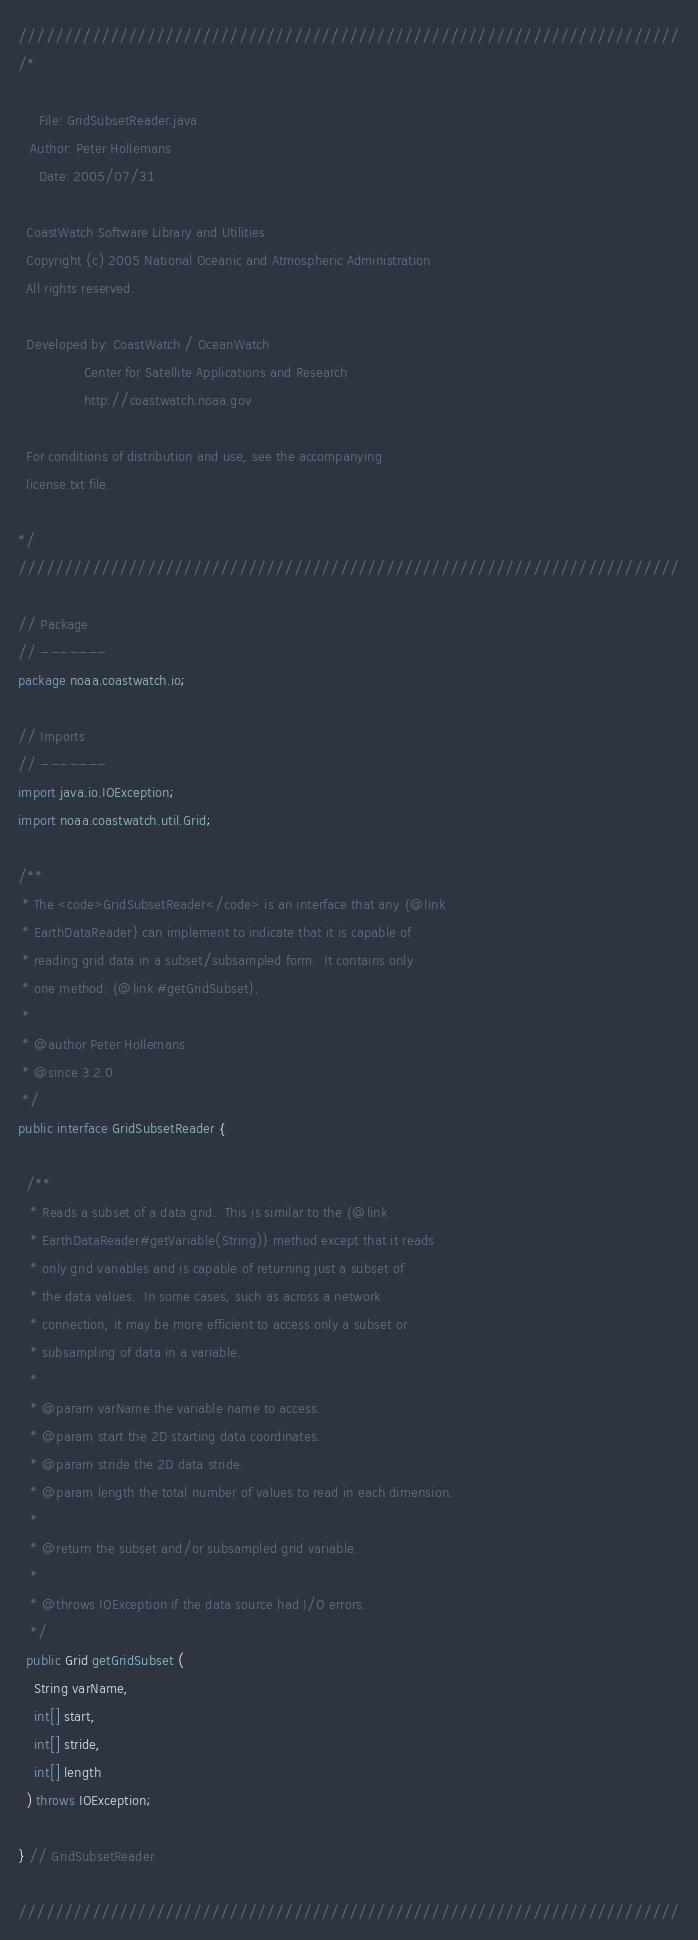<code> <loc_0><loc_0><loc_500><loc_500><_Java_>////////////////////////////////////////////////////////////////////////
/*

     File: GridSubsetReader.java
   Author: Peter Hollemans
     Date: 2005/07/31

  CoastWatch Software Library and Utilities
  Copyright (c) 2005 National Oceanic and Atmospheric Administration
  All rights reserved.

  Developed by: CoastWatch / OceanWatch
                Center for Satellite Applications and Research
                http://coastwatch.noaa.gov

  For conditions of distribution and use, see the accompanying
  license.txt file.

*/
////////////////////////////////////////////////////////////////////////

// Package
// -------
package noaa.coastwatch.io;

// Imports
// -------
import java.io.IOException;
import noaa.coastwatch.util.Grid;

/** 
 * The <code>GridSubsetReader</code> is an interface that any {@link
 * EarthDataReader} can implement to indicate that it is capable of
 * reading grid data in a subset/subsampled form.  It contains only
 * one method: {@link #getGridSubset}.
 *
 * @author Peter Hollemans
 * @since 3.2.0
 */
public interface GridSubsetReader {

  /** 
   * Reads a subset of a data grid.  This is similar to the {@link
   * EarthDataReader#getVariable(String)} method except that it reads
   * only grid variables and is capable of returning just a subset of
   * the data values.  In some cases, such as across a network
   * connection, it may be more efficient to access only a subset or
   * subsampling of data in a variable.
   *
   * @param varName the variable name to access.
   * @param start the 2D starting data coordinates.
   * @param stride the 2D data stride.
   * @param length the total number of values to read in each dimension.
   *
   * @return the subset and/or subsampled grid variable.
   *
   * @throws IOException if the data source had I/O errors.
   */
  public Grid getGridSubset (
    String varName,
    int[] start,
    int[] stride,
    int[] length
  ) throws IOException;

} // GridSubsetReader

////////////////////////////////////////////////////////////////////////
</code> 